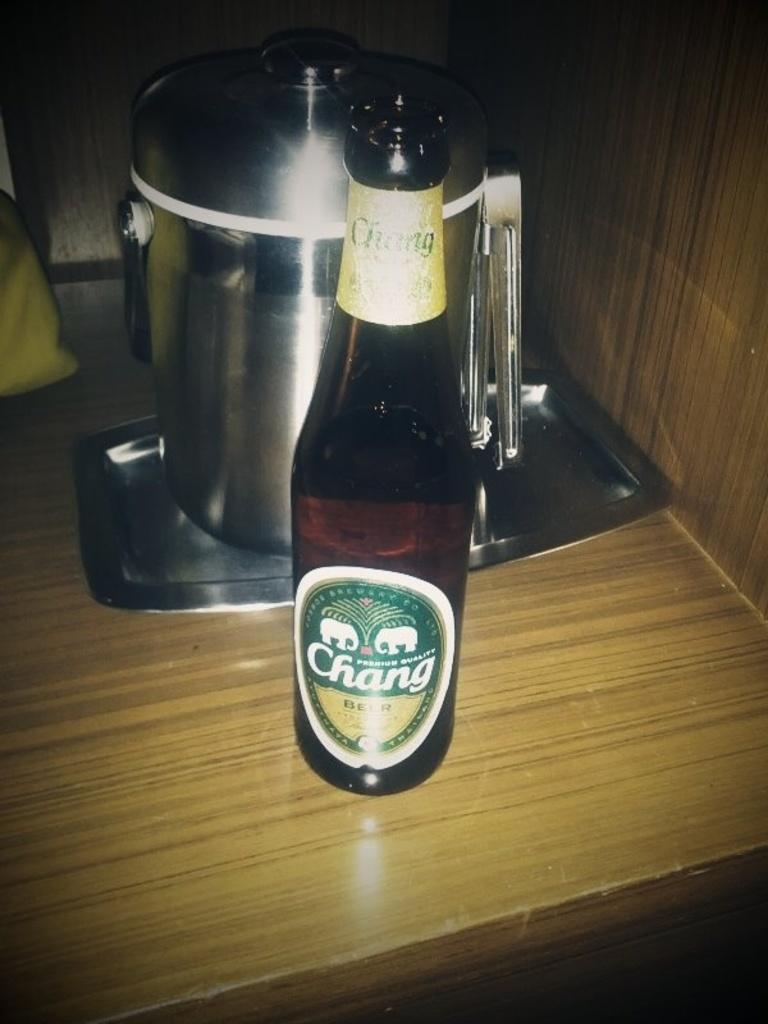What brand of beer is in the bottle?
Keep it short and to the point. Chang. 